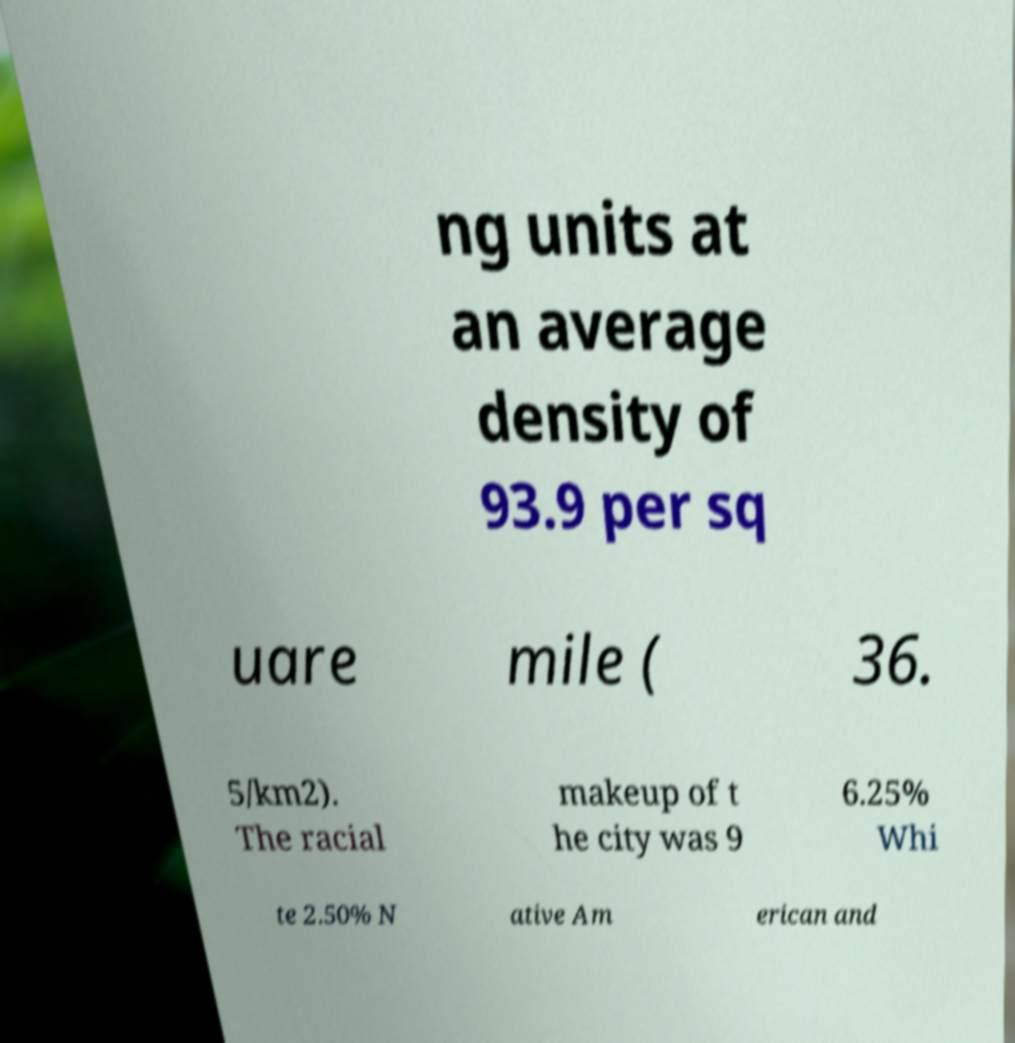For documentation purposes, I need the text within this image transcribed. Could you provide that? ng units at an average density of 93.9 per sq uare mile ( 36. 5/km2). The racial makeup of t he city was 9 6.25% Whi te 2.50% N ative Am erican and 